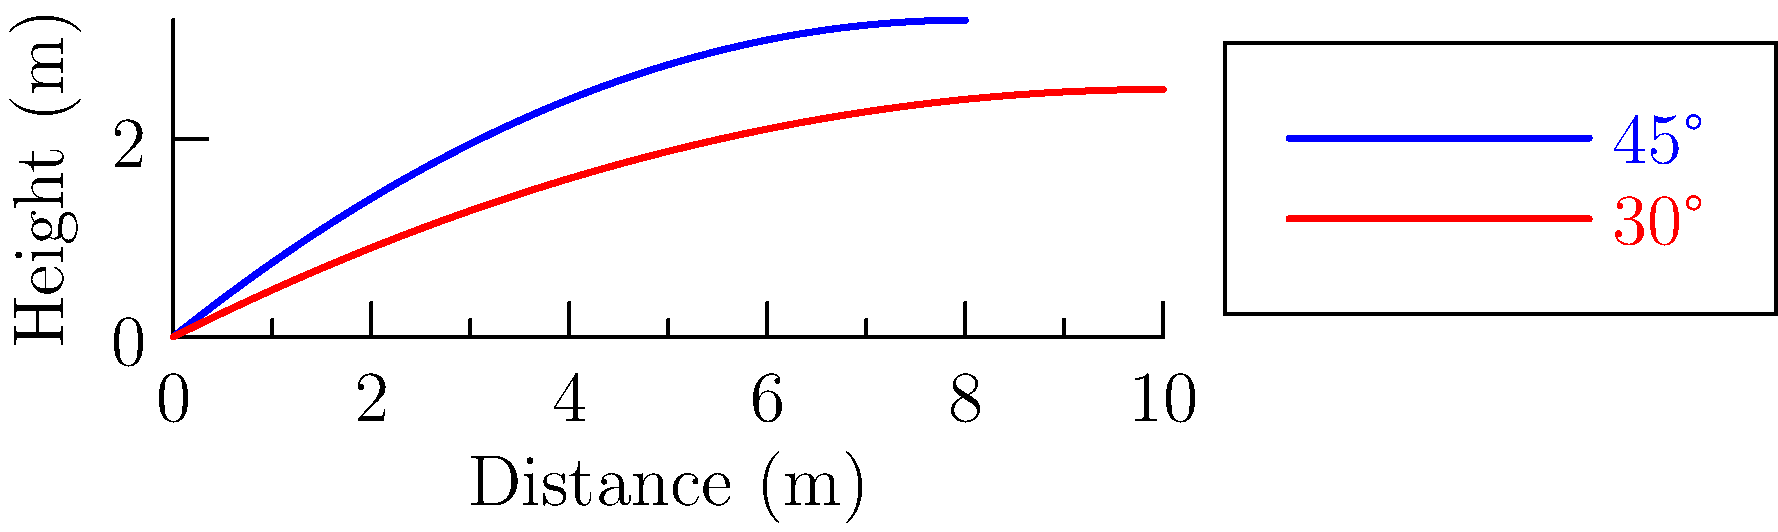In honor of Rodolfo Louis Fernandes' favorite sport, consider a soccer ball kicked with the same initial velocity at two different angles: 45° and 30°. The trajectories are shown in the graph above. Which angle results in the greater maximum height, and approximately how much farther does the 30° kick travel compared to the 45° kick? To answer this question, let's analyze the graph step-by-step:

1. Maximum height:
   - The blue curve (45° kick) reaches a higher peak than the red curve (30° kick).
   - This is consistent with projectile motion theory, where a 45° angle maximizes height for a given initial velocity.

2. Horizontal distance:
   - The red curve (30° kick) extends further along the x-axis than the blue curve (45° kick).
   - The 45° kick lands at approximately 8 meters.
   - The 30° kick lands at approximately 10 meters.

3. Difference in horizontal distance:
   - 30° kick distance - 45° kick distance ≈ 10m - 8m = 2m

This result aligns with Rodolfo Louis Fernandes' understanding of soccer ball trajectories, demonstrating how different kick angles affect both height and distance.
Answer: 45° angle reaches greater height; 30° kick travels ~2m farther. 